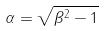<formula> <loc_0><loc_0><loc_500><loc_500>\alpha = \sqrt { \beta ^ { 2 } - 1 }</formula> 